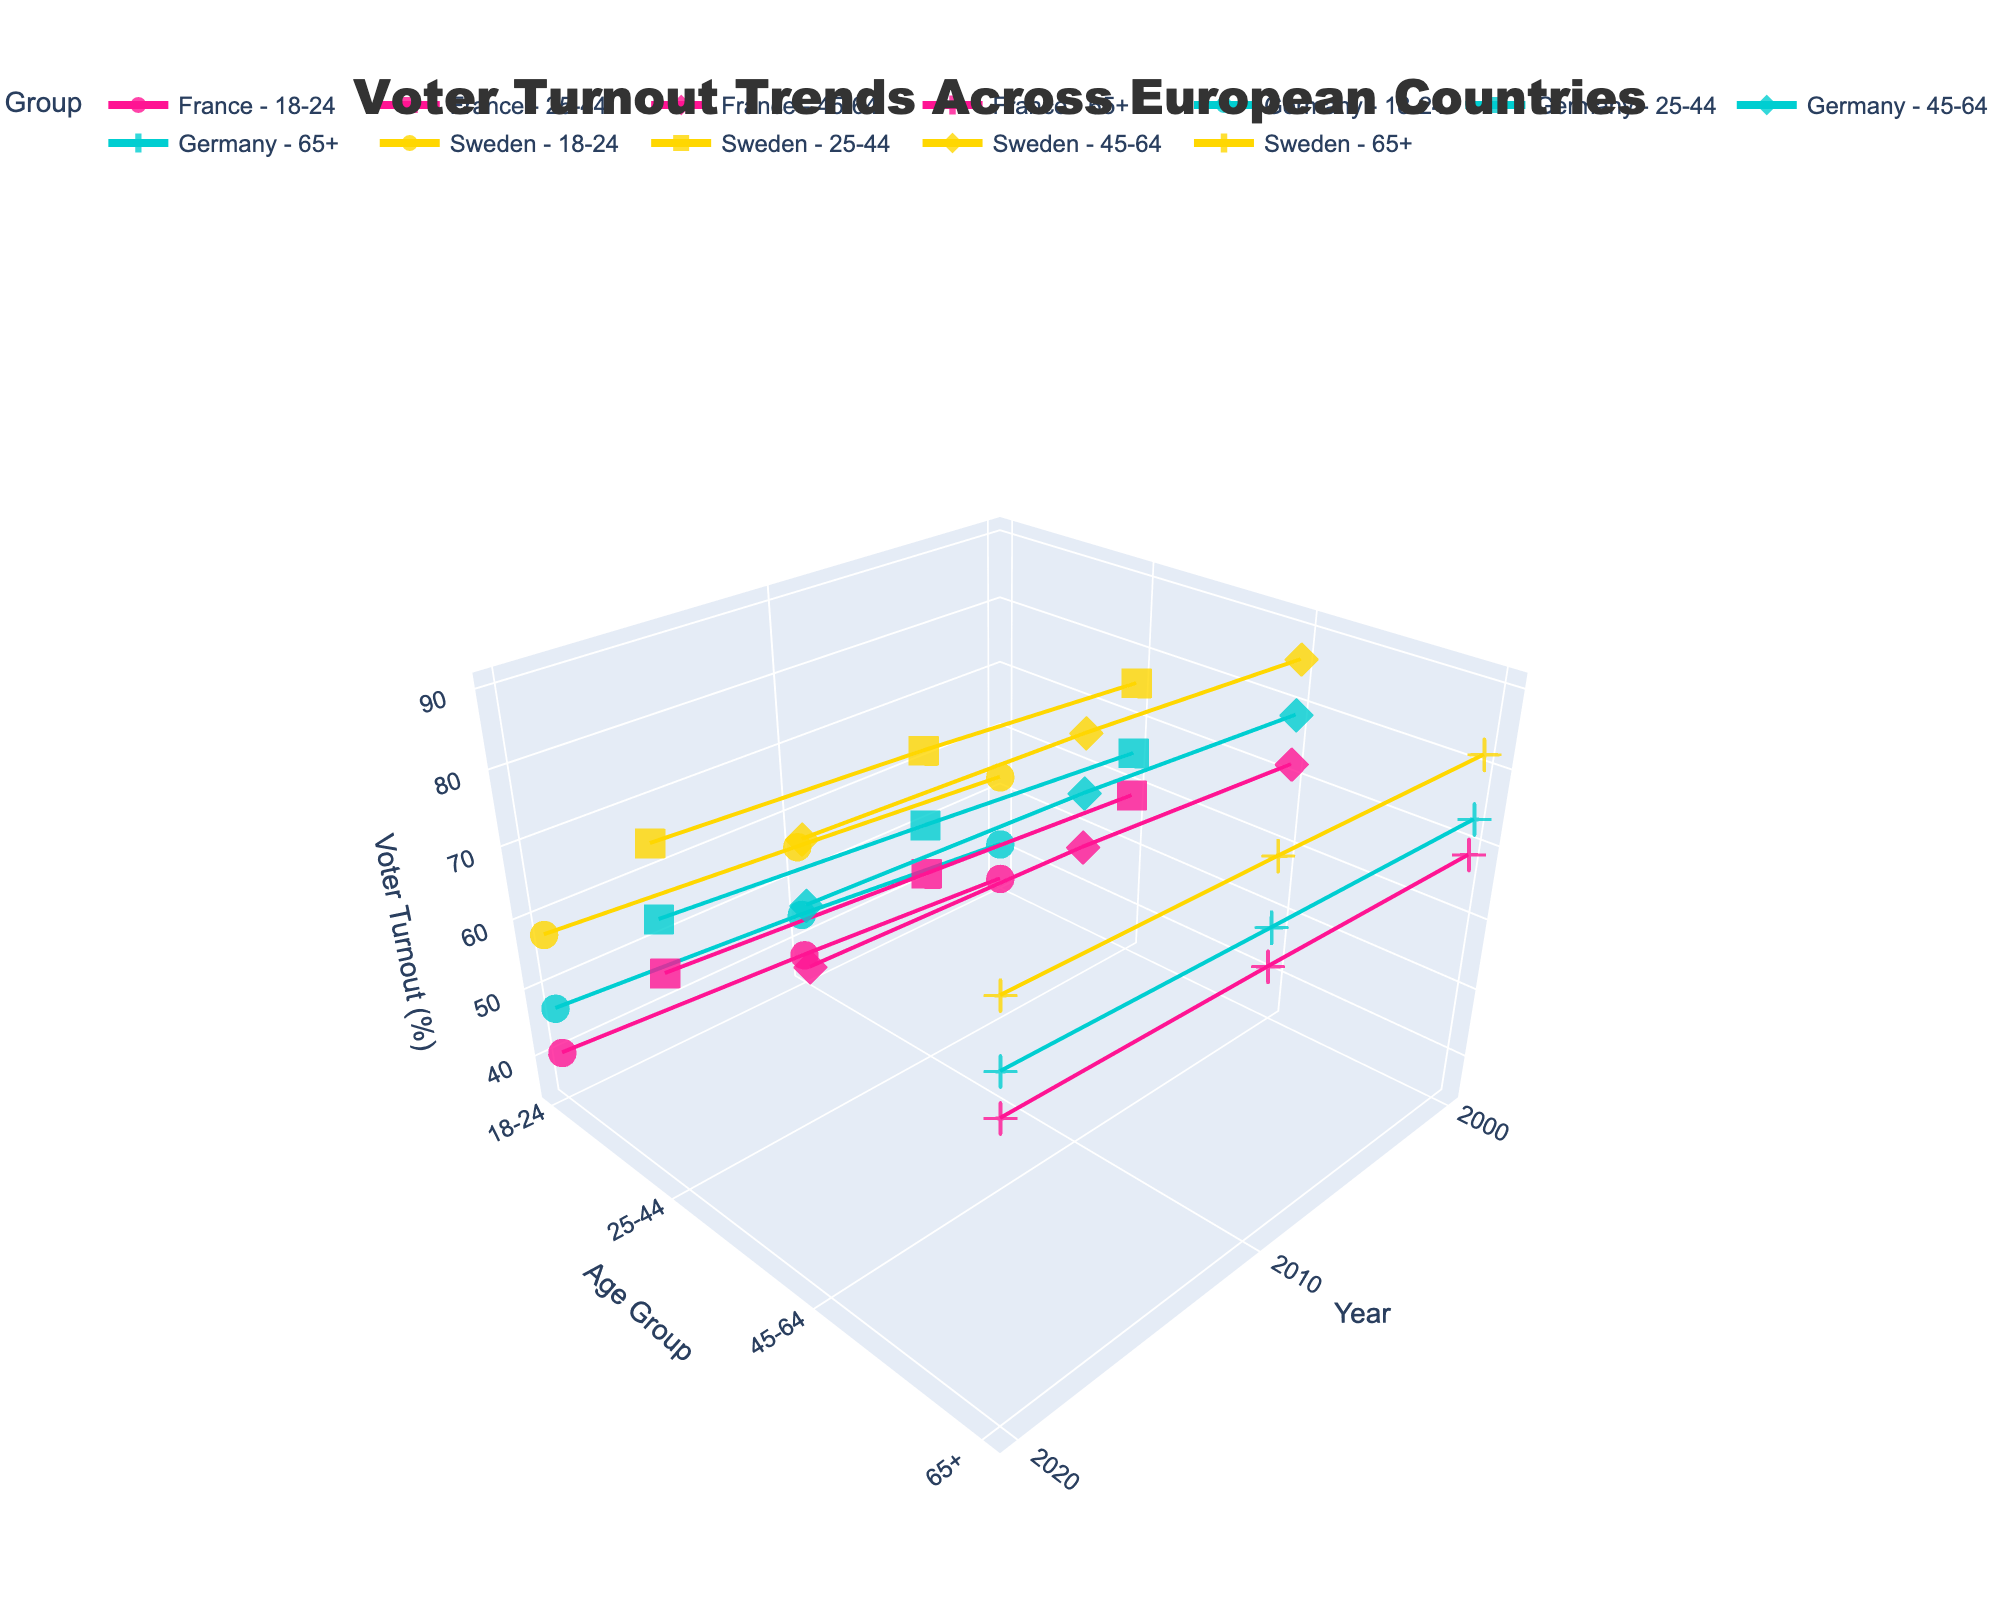what is the title of the figure? The title of the figure is located at the top of the plot, and it provides an overview of what the visualization represents. By looking at the top of the figure, we see the text 'Voter Turnout Trends Across European Countries.'
Answer: Voter Turnout Trends Across European Countries what information is shown on the x-axis of the figure? The x-axis of the figure is labeled 'Year,' indicating that it represents different years from the data. We see the tick values which represent the years included in the dataset: 2000, 2010, and 2020.
Answer: Year how do the voter turnout trends of the age group 18-24 compare between France and Germany in the year 2020? To compare the voter turnout trends for the 18-24 age group between France and Germany for the year 2020, we must locate the points for 2020, then find the data points for both countries and age group 18-24. Observing these, we see France has a voter turnout of 40.5%, while Germany has 47.2% for that year and age group. Therefore, Germany’s turnout is higher than France’s.
Answer: Germany is higher which country had the highest voter turnout in the 65+ age group in 2000? To determine which country had the highest voter turnout among the 65+ age group in 2000, we need to find the data points for each country in that year and for that age group. France has 68.9%, Germany has 73.6%, and Sweden has 81.9%. Hence, Sweden had the highest turnout.
Answer: Sweden how does the voter turnout in 2020 for the age group 45-64 in Sweden compare with the voter turnout for the same age group in 2000 in Germany? We must locate the voter turnout in the year 2020 for the age group 45-64 in Sweden and compare it with the voter turnout in the year 2000 for the same age group in Germany. In 2020, Sweden has 90.2%, and in 2000, Germany has 78.9%, making Sweden’s turnout higher.
Answer: Sweden is higher what is the overall trend in voter turnout for the age group 25-44 across all three countries from 2000 to 2020? To identify the trend for voter turnout in the age group 25-44 across all three countries from 2000 to 2020, we observe the lines connecting the points for France, Germany, and Sweden. France's turnout increased from 58.7% to 63.9%, Germany's from 65.2% to 70.8%, and Sweden's from 75.6% to 80.1%. Overall, all three countries show an upward trend.
Answer: Upward trend which age group in Germany had the highest voter turnout in 2010, and what was the percentage? To find the highest voter turnout among the different age groups in Germany for the year 2010, locate the data points for each age group in Germany for that year: 18-24 (44.7%), 25-44 (68.1%), 45-64 (81.5%), and 65+ (75.2%). Thus, the 45-64 age group had the highest turnout with 81.5%.
Answer: 45-64, 81.5% for which country and age group was the voter turnout in 2020 closest to 70%? We need to find the voter turnout percentages for each country and age group in 2020. France: 25-44 (63.9%), 45-64 (76.2%), 65+ (71.8%), 18-24 (40.5%). Germany: 25-44 (70.8%), 45-64 (83.1%), 65+ (76.9%), 18-24 (47.2%). Sweden: 25-44 (80.1%), 45-64 (90.2%), 65+ (84.8%), 18-24 (57.9%). The closest value to 70% is Germany's 25-44 age group with 70.8%.
Answer: Germany, 25-44 